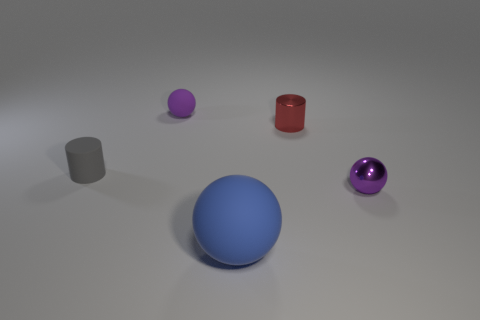Is there a small matte thing that has the same color as the shiny ball?
Provide a short and direct response. Yes. There is a tiny metal object that is in front of the tiny gray matte cylinder; are there any large blue balls that are on the right side of it?
Your response must be concise. No. Is there a large ball made of the same material as the big thing?
Provide a succinct answer. No. What material is the tiny red cylinder that is behind the purple ball that is right of the blue rubber thing made of?
Your answer should be very brief. Metal. What is the material of the sphere that is to the left of the metal cylinder and behind the large sphere?
Your answer should be compact. Rubber. Are there the same number of small gray matte objects that are to the right of the big blue matte thing and shiny cylinders?
Give a very brief answer. No. How many other gray rubber objects are the same shape as the tiny gray matte object?
Make the answer very short. 0. There is a matte ball behind the matte sphere that is in front of the purple thing that is left of the tiny purple shiny thing; how big is it?
Provide a succinct answer. Small. Does the thing that is in front of the small purple metallic object have the same material as the red cylinder?
Provide a short and direct response. No. Are there the same number of tiny purple metal balls that are to the right of the small red metal object and small gray matte objects behind the big blue matte ball?
Ensure brevity in your answer.  Yes. 